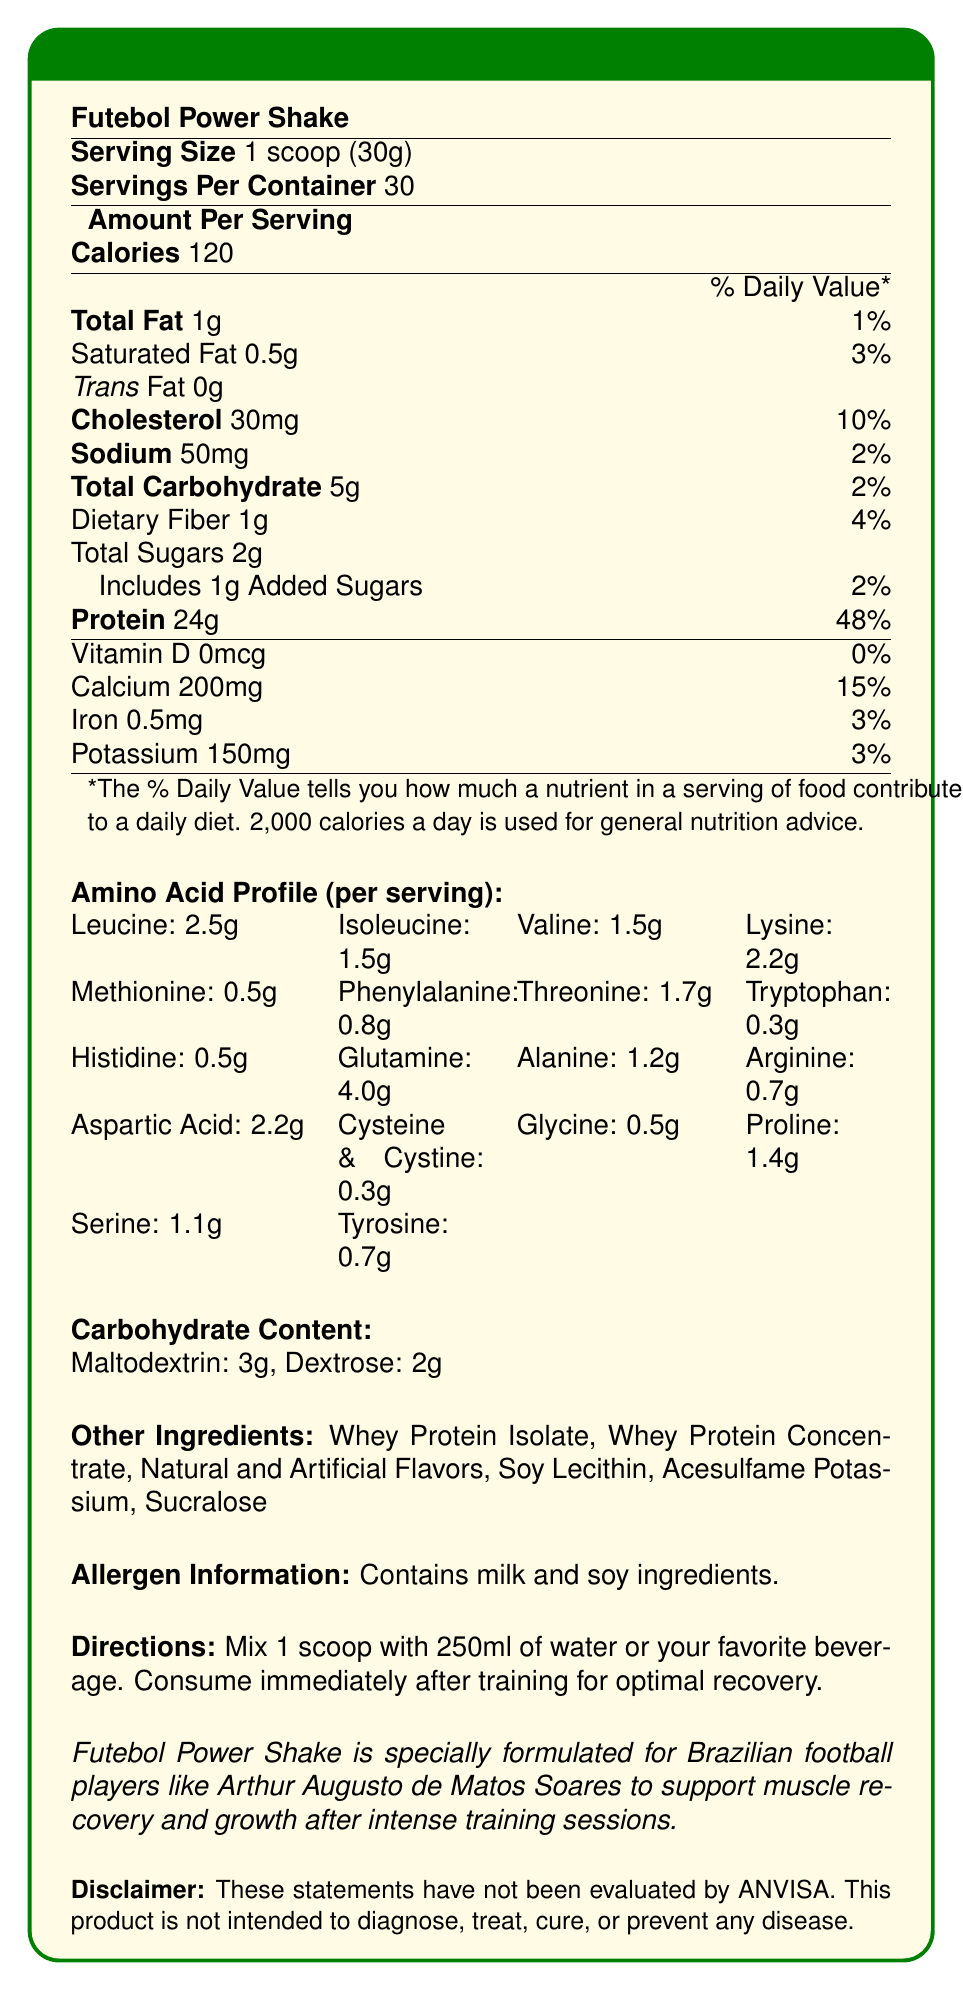what is the serving size of the Futebol Power Shake? The serving size specified in the document is 1 scoop, equivalent to 30 grams.
Answer: 1 scoop (30g) how many total carbohydrates are in one serving of the Futebol Power Shake? The document states that each serving contains 5 grams of total carbohydrates.
Answer: 5g what is the amount of leucine per serving in the Futebol Power Shake? The amino acid profile lists leucine as 2.5 grams per serving.
Answer: 2.5g how much protein is in one serving of the Futebol Power Shake? The document specifies that there are 24 grams of protein per serving.
Answer: 24g how many total calories are in each serving of the Futebol Power Shake? Each serving of the Futebol Power Shake contains 120 calories.
Answer: 120 which of the following amino acids is present in the highest amount? (A) Glutamine (B) Valine (C) Alanine (D) Glycine The amino acid profile shows that glutamine is present in the highest amount at 4.0 grams per serving, compared to valine (1.5g), alanine (1.2g), and glycine (0.5g).
Answer: A what is the total carbohydrate content, including both maltodextrin and dextrose? (1) 2g (2) 3g (3) 5g (4) 7g The document states 3g of maltodextrin and 2g of dextrose, totaling 5g.
Answer: 3 is there any cholesterol in the Futebol Power Shake? The document lists 30mg of cholesterol per serving.
Answer: Yes summarize the main nutritional benefits of the Futebol Power Shake. The document outlines the significant components and benefits of the Futebol Power Shake, emphasizing its protein content, amino acid profile, and carbohydrate sources beneficial for recovery after training sessions.
Answer: The Futebol Power Shake provides a high amount of protein (24g per serving) which aids in muscle recovery and growth. It includes a comprehensive amino acid profile and moderate carbohydrate content to support energy replenishment. how much calcium is in each serving? The amount of calcium per serving is specified as 200mg in the document.
Answer: 200mg is Futebol Power Shake evaluated by ANVISA for disease treatment or prevention? The disclaimer clearly states that the product is not intended to diagnose, treat, cure, or prevent any disease, and these statements have not been evaluated by ANVISA.
Answer: No which ingredient is not listed under "Other Ingredients"? (A) Whey Protein Isolate (B) Natural Flavors (C) Soy Lecithin (D) Creatine Creatine is not listed under "Other Ingredients"; the listed components are Whey Protein Isolate, Natural and Artificial Flavors, and Soy Lecithin.
Answer: D how should you consume the Futebol Power Shake for optimal recovery? The document directs to mix one scoop with 250ml of water or another beverage and consume it right after training for the best recovery results.
Answer: Mix 1 scoop with 250ml of water or your favorite beverage and consume immediately after training. identify the allergen information provided in the document. The allergen information section in the document specifies that it contains milk and soy ingredients.
Answer: Contains milk and soy ingredients. how many servings are there in one container of Futebol Power Shake? The document states there are 30 servings per container.
Answer: 30 what is the percentage daily value of protein per serving? According to the document, one serving of Futebol Power Shake provides 48% of the daily value for protein.
Answer: 48% who is the Futebol Power Shake specially formulated for? The brand statement mentions that the shake is specially formulated for Brazilian football players, using Arthur Augusto de Matos Soares as an example.
Answer: Brazilian football players like Arthur Augusto de Matos Soares what is the amount of iron in each serving? The document states that each serving contains 0.5mg of iron.
Answer: 0.5mg which amino acids are present in the same amount per serving? (A) Glutamine and Threonine (B) Methionine and Histidine (C) Leucine and Lysine (D) Valine and Aspartic Acid Both Methionine and Histidine are present in equal amounts of 0.5 grams per serving.
Answer: B how many grams of maltodextrin are there per serving? The carbohydrate content section specifies that there are 3 grams of maltodextrin per serving.
Answer: 3g describe the directions for using the product. The directions instruct the user to mix one scoop with 250ml of water or another beverage and consume it right after training to maximize recovery benefits.
Answer: Mix 1 scoop with 250ml of water or your favorite beverage and consume immediately after training for optimal recovery. how much dietary fiber is in one serving of Futebol Power Shake? The document states that each serving contains 1 gram of dietary fiber.
Answer: 1g which statement best describes the purposes of the Futebol Power Shake? (I) Weight loss (II) Muscle recovery and growth (III) Intense training support (IV) Energy boost The product is designed to support muscle recovery and growth after intense training sessions.
Answer: II and III are there any details about the non-nutritional benefits of the Futebol Power Shake? The document focuses on nutritional information and directions for use. It does not provide details about non-nutritional benefits.
Answer: Cannot be determined 